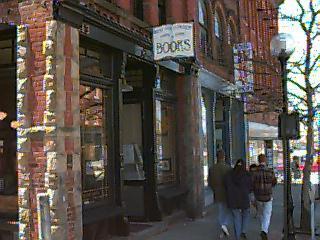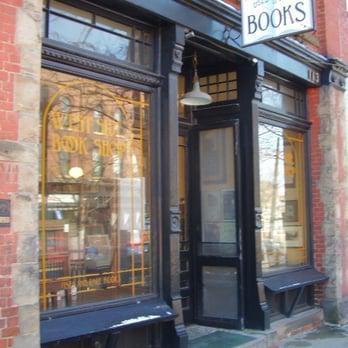The first image is the image on the left, the second image is the image on the right. For the images displayed, is the sentence "A sign hangs outside the door of a brick bookstore in each of the images." factually correct? Answer yes or no. Yes. 